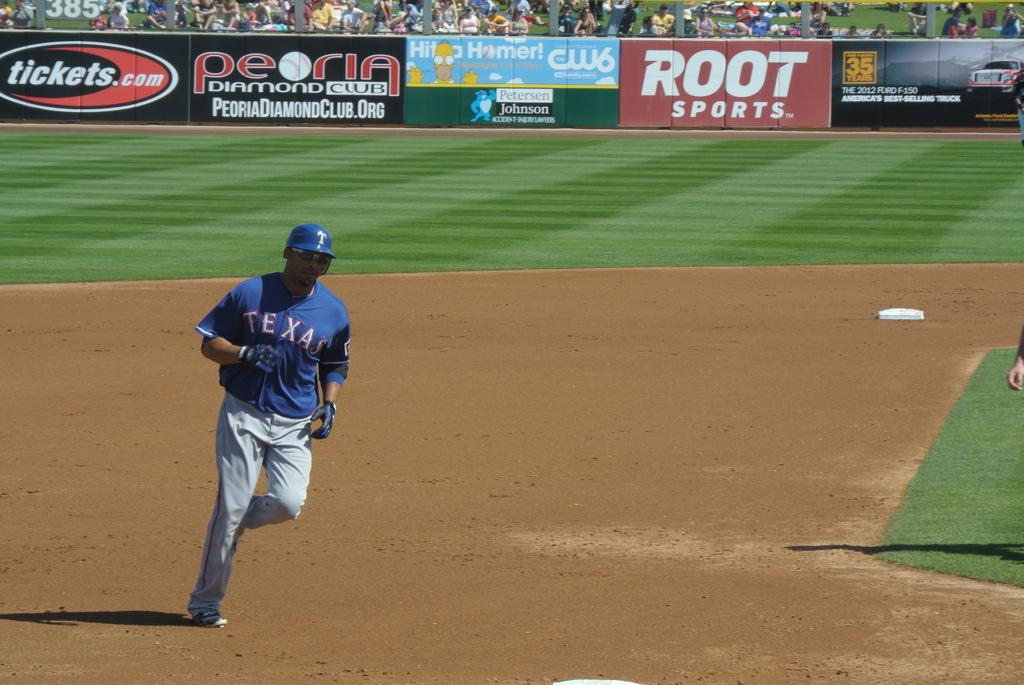<image>
Provide a brief description of the given image. The player from the texas team is running on the pitch. 